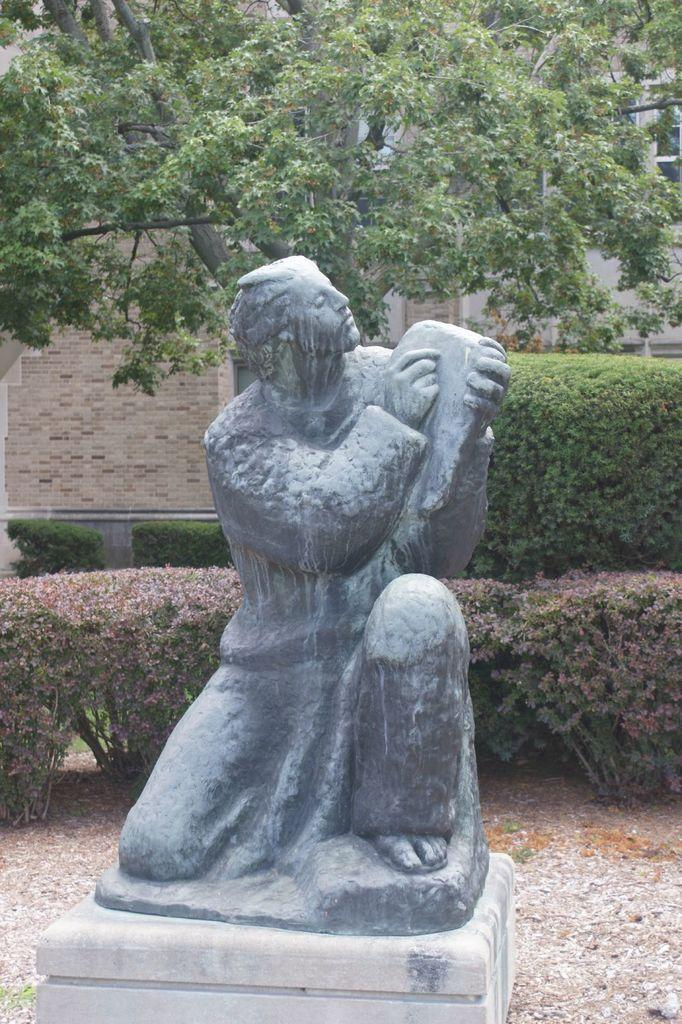What is the main subject in the image? There is a statue in the image. What can be seen in the background of the image? There is a building in the background of the image. Are there any natural elements in the image? Yes, there is a tree and plants in the image. What type of surface is visible in the image? There is ground visible in the image. How many kittens are playing on the road in the image? There are no kittens or roads present in the image. What type of trees can be seen in the image? The provided facts do not specify the type of trees in the image, only that there is a tree present. 